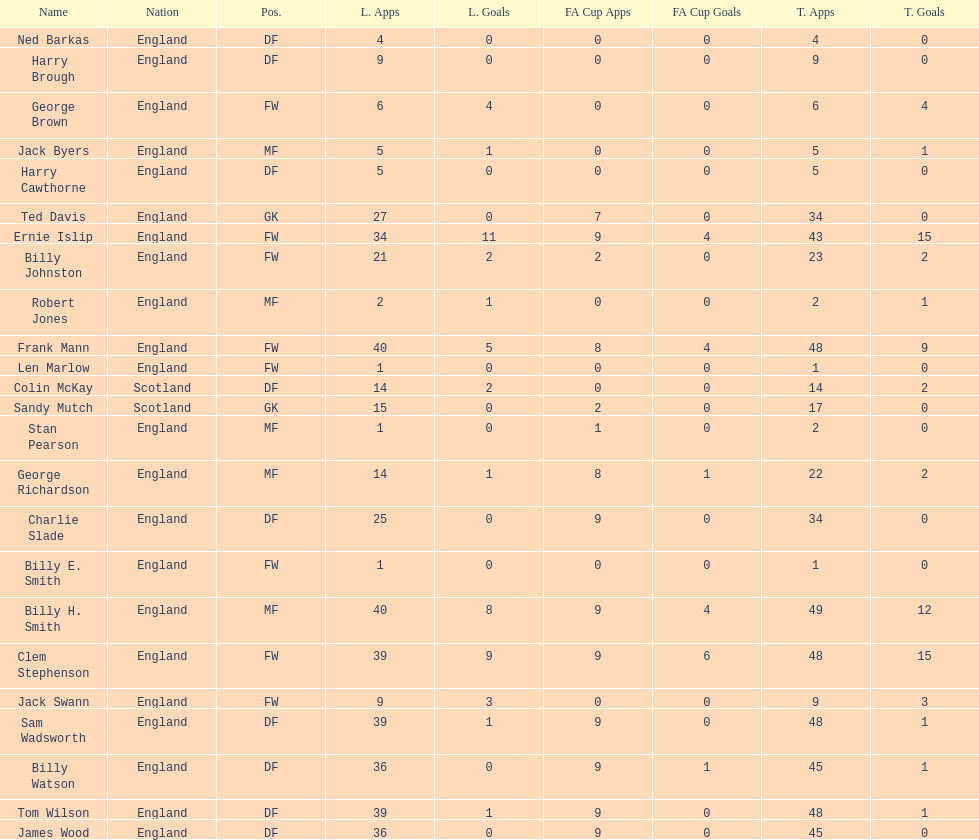What is the mean number of goals that scottish players score? 1. 